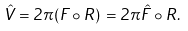<formula> <loc_0><loc_0><loc_500><loc_500>\hat { V } = 2 \pi ( F \circ R ) \, = 2 \pi \hat { F } \circ R .</formula> 